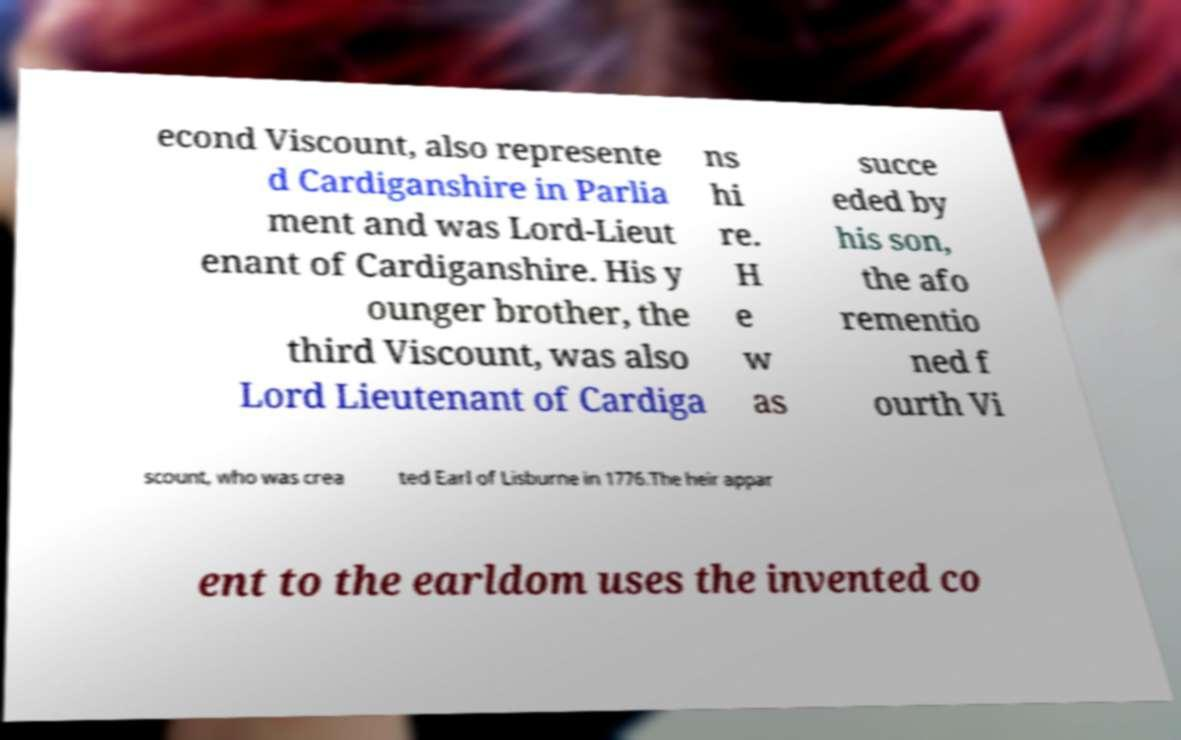Can you read and provide the text displayed in the image?This photo seems to have some interesting text. Can you extract and type it out for me? econd Viscount, also represente d Cardiganshire in Parlia ment and was Lord-Lieut enant of Cardiganshire. His y ounger brother, the third Viscount, was also Lord Lieutenant of Cardiga ns hi re. H e w as succe eded by his son, the afo rementio ned f ourth Vi scount, who was crea ted Earl of Lisburne in 1776.The heir appar ent to the earldom uses the invented co 